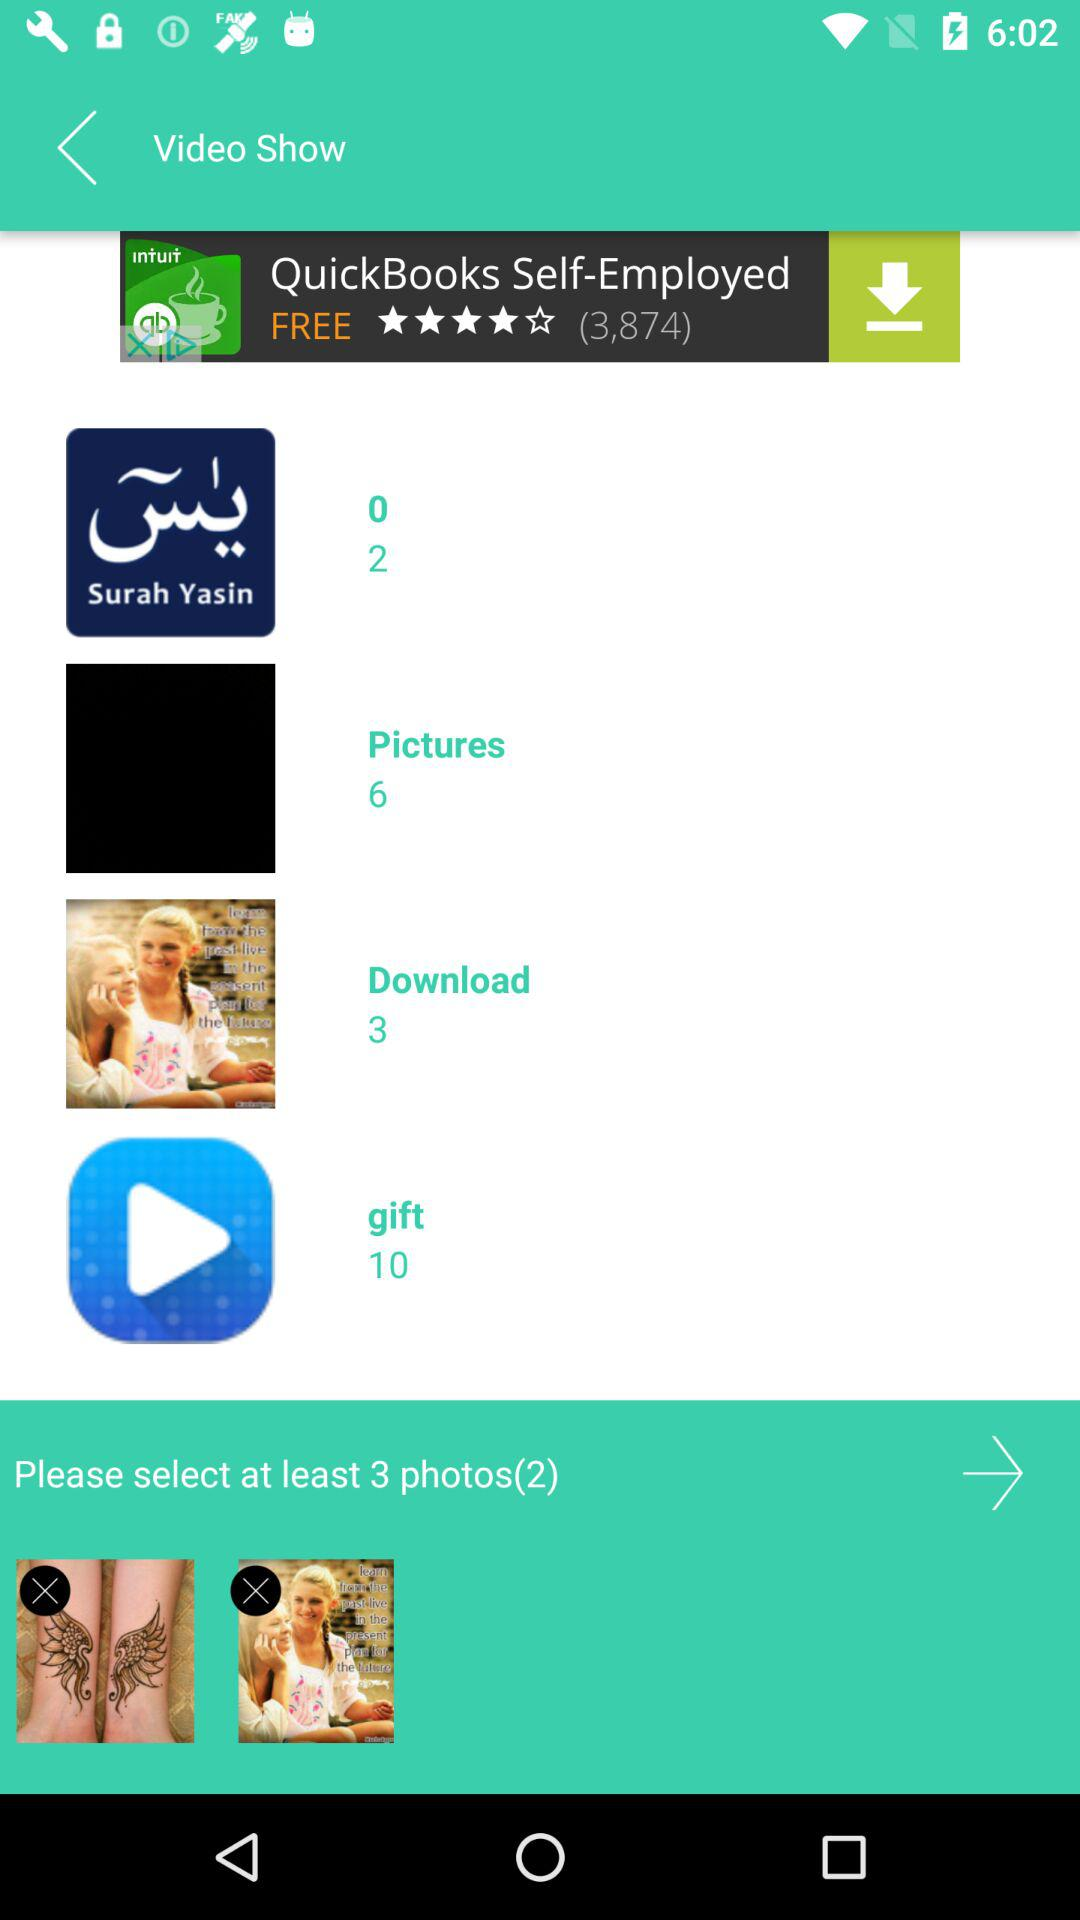What is the number of images in the "Download" album? The number of images in the "Download" album is 3. 